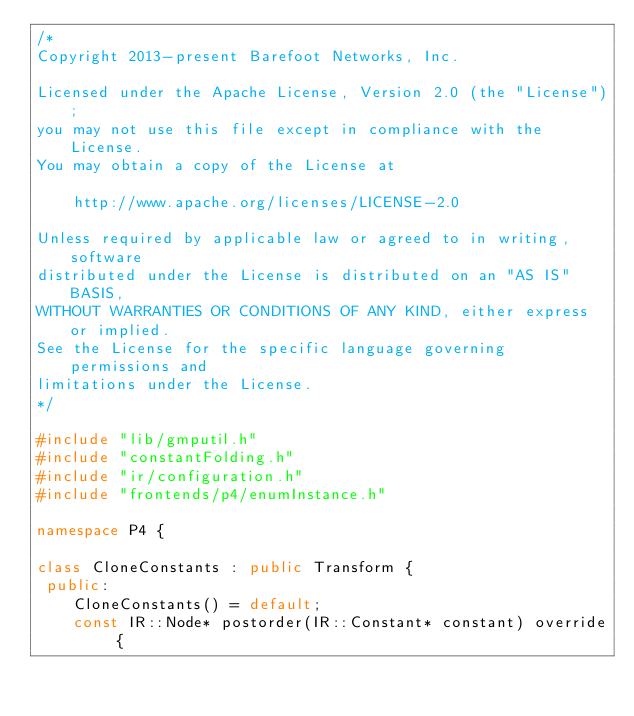<code> <loc_0><loc_0><loc_500><loc_500><_C++_>/*
Copyright 2013-present Barefoot Networks, Inc.

Licensed under the Apache License, Version 2.0 (the "License");
you may not use this file except in compliance with the License.
You may obtain a copy of the License at

    http://www.apache.org/licenses/LICENSE-2.0

Unless required by applicable law or agreed to in writing, software
distributed under the License is distributed on an "AS IS" BASIS,
WITHOUT WARRANTIES OR CONDITIONS OF ANY KIND, either express or implied.
See the License for the specific language governing permissions and
limitations under the License.
*/

#include "lib/gmputil.h"
#include "constantFolding.h"
#include "ir/configuration.h"
#include "frontends/p4/enumInstance.h"

namespace P4 {

class CloneConstants : public Transform {
 public:
    CloneConstants() = default;
    const IR::Node* postorder(IR::Constant* constant) override {</code> 